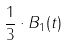<formula> <loc_0><loc_0><loc_500><loc_500>\frac { 1 } { 3 } \cdot B _ { 1 } ( t )</formula> 